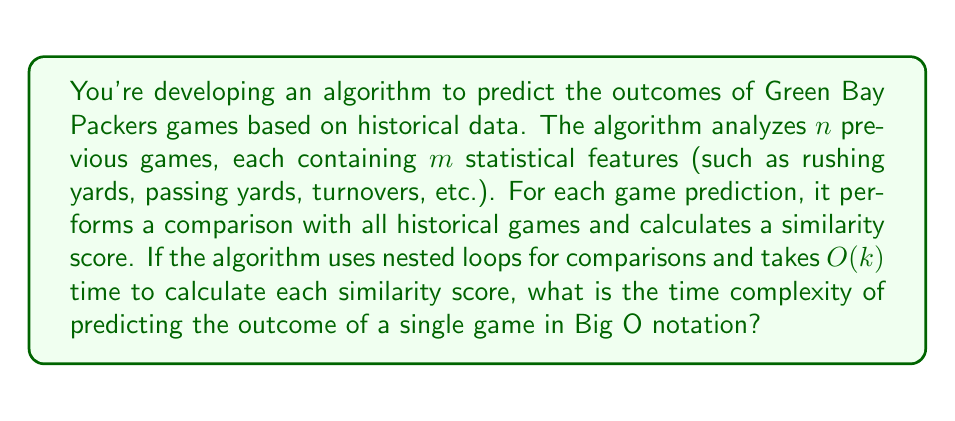Give your solution to this math problem. Let's break down the algorithm's steps and analyze its time complexity:

1) The algorithm needs to iterate through all $n$ historical games. This forms our outer loop.

2) For each historical game, it needs to compare $m$ statistical features with the current game. This forms our inner loop.

3) Within the inner loop, it calculates a similarity score, which takes $O(k)$ time.

The structure of the algorithm can be represented as:

```
for each historical game (n times):
    for each feature (m times):
        calculate similarity score (O(k) time)
```

To determine the overall time complexity:

1) The innermost operation (similarity score calculation) takes $O(k)$ time.

2) This operation is performed $m$ times for each feature comparison.

3) The feature comparison loop is executed $n$ times for each historical game.

Therefore, the total time complexity is:

$$ O(n \cdot m \cdot k) $$

This represents the number of basic operations performed by the algorithm in the worst-case scenario.

Note: In Big O notation, we typically don't multiply the terms but rather list them in order of nested operations. So, the final answer would be $O(nmk)$.
Answer: $O(nmk)$ 